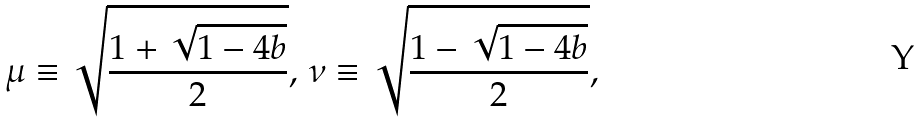<formula> <loc_0><loc_0><loc_500><loc_500>\mu \equiv \sqrt { \frac { 1 + \sqrt { 1 - 4 b } } { 2 } } , \, \nu \equiv \sqrt { \frac { 1 - \sqrt { 1 - 4 b } } { 2 } } ,</formula> 